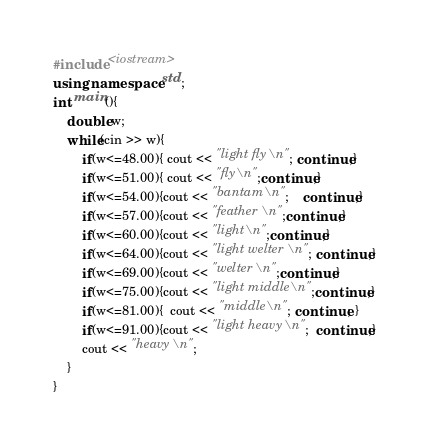Convert code to text. <code><loc_0><loc_0><loc_500><loc_500><_C++_>#include <iostream>
using namespace std;
int main(){
    double w;
    while(cin >> w){
        if(w<=48.00){ cout << "light fly\n"; continue;}
        if(w<=51.00){ cout << "fly\n";continue;}
        if(w<=54.00){cout << "bantam\n";    continue;}
        if(w<=57.00){cout << "feather\n";continue;}
        if(w<=60.00){cout << "light\n";continue;}
        if(w<=64.00){cout << "light welter\n"; continue;}
        if(w<=69.00){cout << "welter\n";continue;}
        if(w<=75.00){cout << "light middle\n";continue;}
        if(w<=81.00){  cout << "middle\n"; continue; }
        if(w<=91.00){cout << "light heavy\n";  continue;}
        cout << "heavy\n";
    }
}</code> 